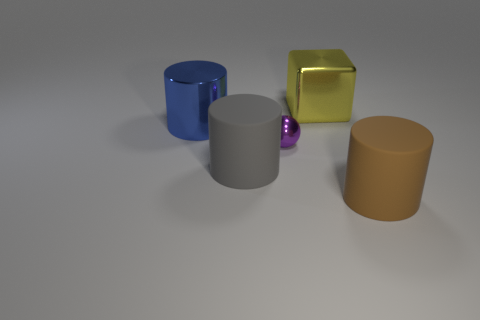Add 2 tiny green cubes. How many objects exist? 7 Subtract all spheres. How many objects are left? 4 Subtract 0 green spheres. How many objects are left? 5 Subtract all rubber things. Subtract all big red cubes. How many objects are left? 3 Add 2 big brown cylinders. How many big brown cylinders are left? 3 Add 1 large yellow objects. How many large yellow objects exist? 2 